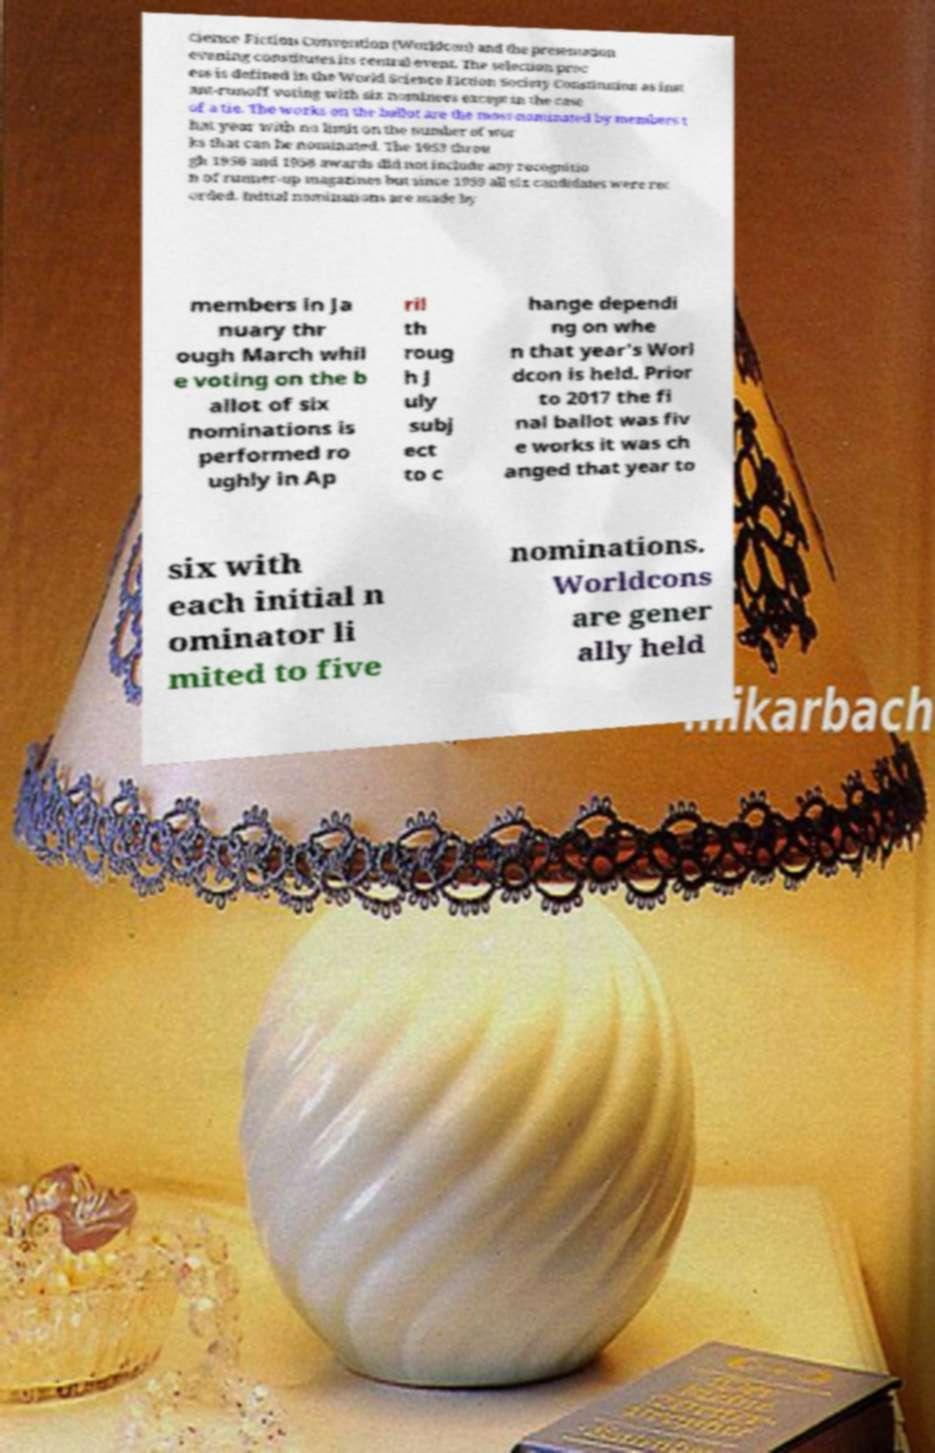Please read and relay the text visible in this image. What does it say? cience Fiction Convention (Worldcon) and the presentation evening constitutes its central event. The selection proc ess is defined in the World Science Fiction Society Constitution as inst ant-runoff voting with six nominees except in the case of a tie. The works on the ballot are the most-nominated by members t hat year with no limit on the number of wor ks that can be nominated. The 1953 throu gh 1956 and 1958 awards did not include any recognitio n of runner-up magazines but since 1959 all six candidates were rec orded. Initial nominations are made by members in Ja nuary thr ough March whil e voting on the b allot of six nominations is performed ro ughly in Ap ril th roug h J uly subj ect to c hange dependi ng on whe n that year's Worl dcon is held. Prior to 2017 the fi nal ballot was fiv e works it was ch anged that year to six with each initial n ominator li mited to five nominations. Worldcons are gener ally held 